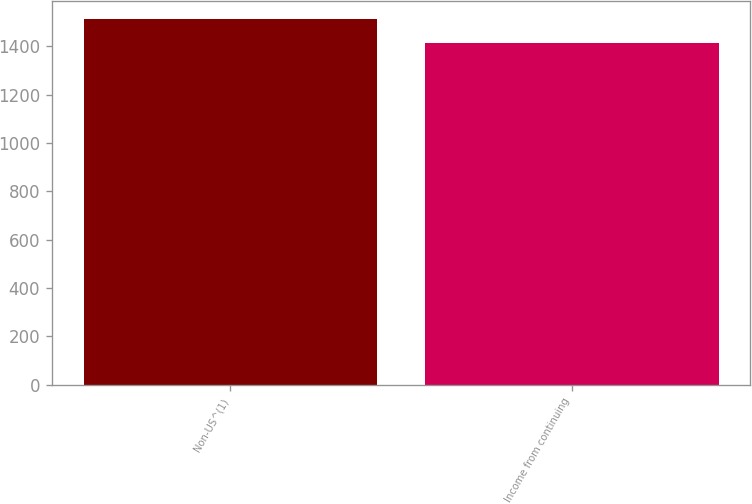Convert chart. <chart><loc_0><loc_0><loc_500><loc_500><bar_chart><fcel>Non-US^(1)<fcel>Income from continuing<nl><fcel>1511<fcel>1415<nl></chart> 